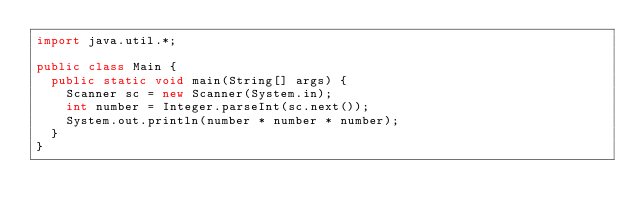<code> <loc_0><loc_0><loc_500><loc_500><_Java_>import java.util.*;

public class Main {
  public static void main(String[] args) {
    Scanner sc = new Scanner(System.in);
    int number = Integer.parseInt(sc.next());
    System.out.println(number * number * number);
  }
}
</code> 